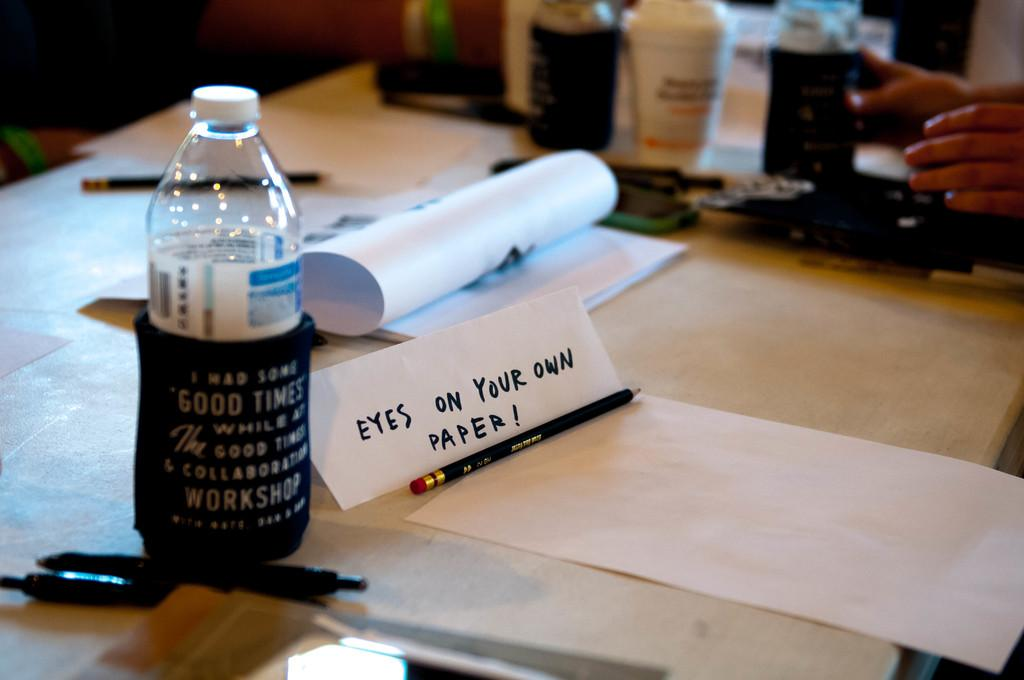<image>
Create a compact narrative representing the image presented. A water bottle with a warmer mentioning good times. 